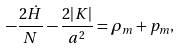Convert formula to latex. <formula><loc_0><loc_0><loc_500><loc_500>- \frac { 2 \dot { H } } { N } - \frac { 2 | K | } { a ^ { 2 } } = \rho _ { m } + p _ { m } ,</formula> 